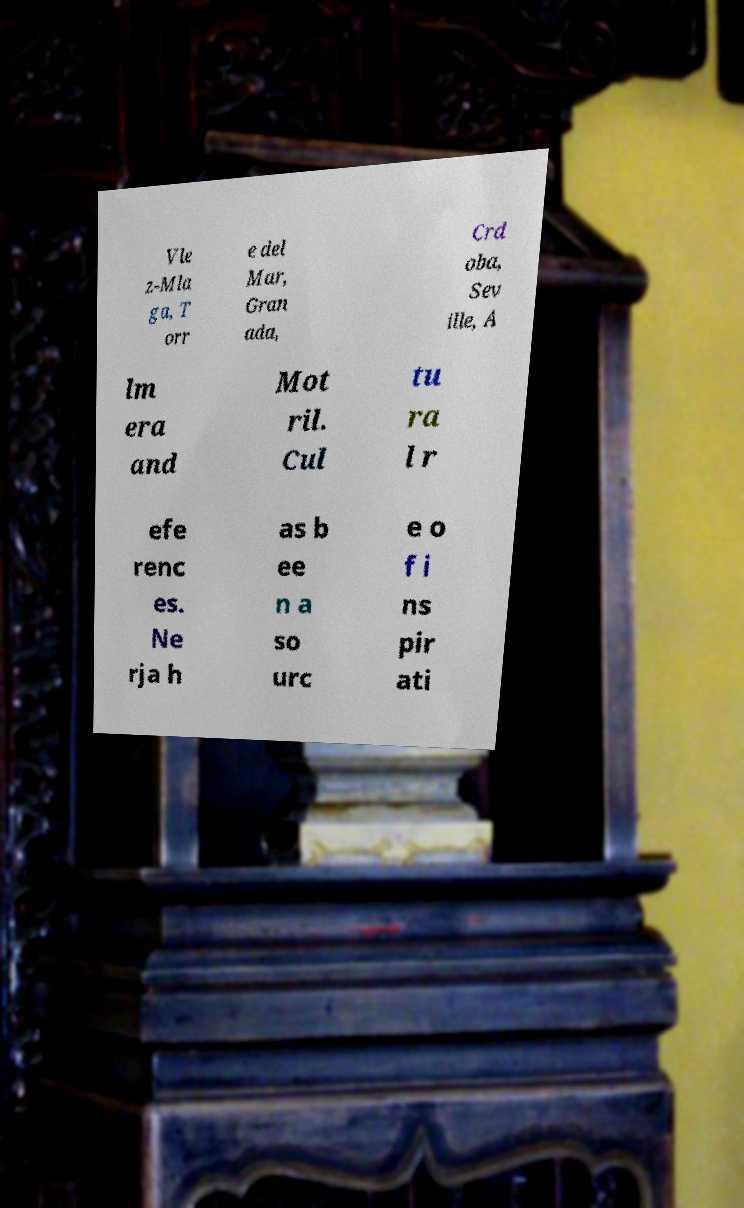What messages or text are displayed in this image? I need them in a readable, typed format. Vle z-Mla ga, T orr e del Mar, Gran ada, Crd oba, Sev ille, A lm era and Mot ril. Cul tu ra l r efe renc es. Ne rja h as b ee n a so urc e o f i ns pir ati 